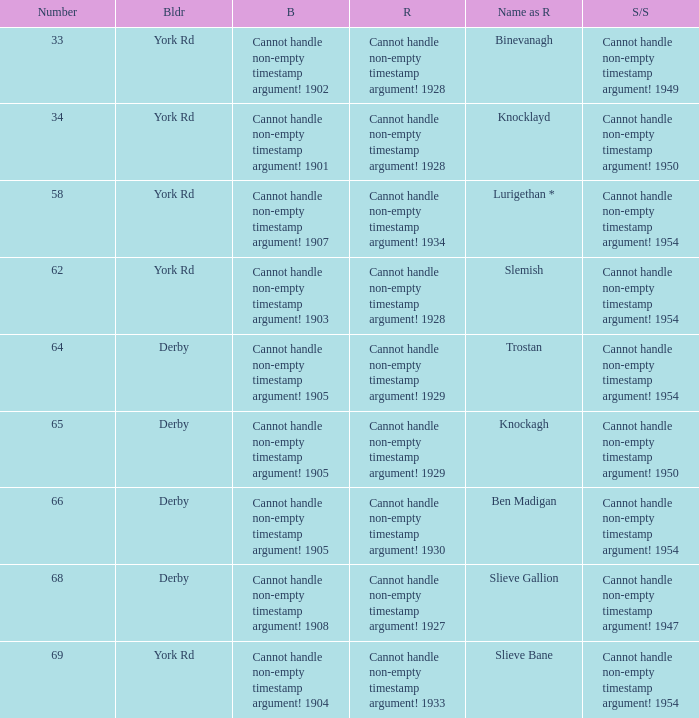Which Rebuilt has a Builder of derby, and a Name as rebuilt of ben madigan? Cannot handle non-empty timestamp argument! 1930. 